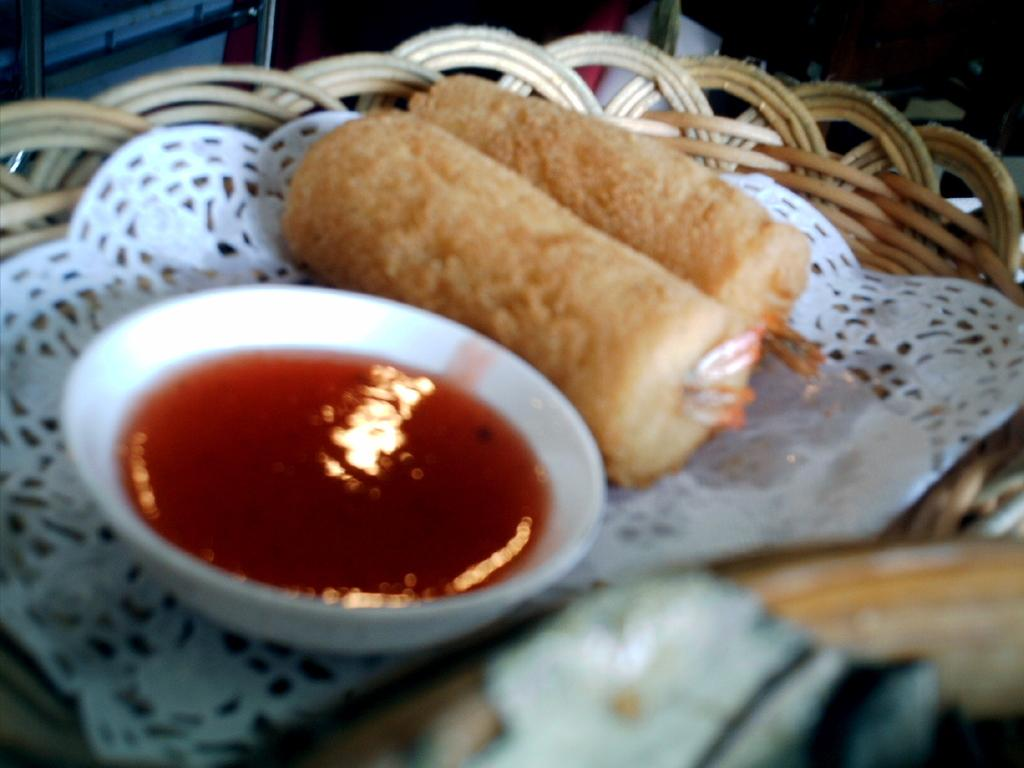What is located at the bottom of the image? There is a basket at the bottom of the image. What is inside the basket? There is food and a cup in the basket. Can you describe the type of food in the basket? The facts provided do not specify the type of food in the basket. How many oranges are on the table in the image? There is no table or oranges present in the image; it only features a basket with food and a cup. What is the purpose of the basket in the image? The facts provided do not specify the purpose of the basket in the image. 